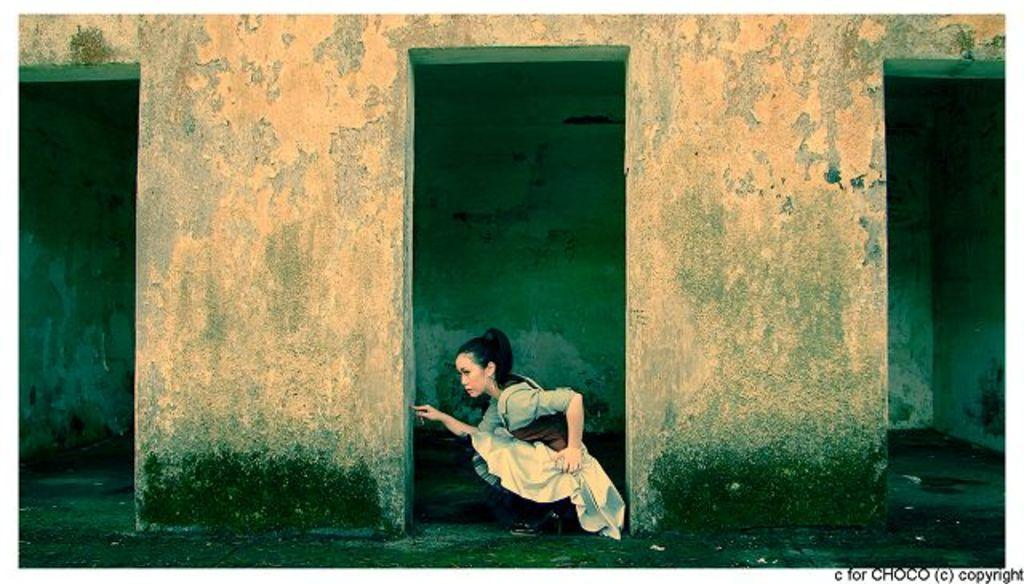Who is the main subject in the image? There is a woman in the image. Can you describe the woman's position in relation to the pillars? The woman is positioned between pillars. What can be seen behind the woman in the image? There is a wall visible behind the woman. What type of bulb is being used for the woman's treatment in the image? There is no indication of any treatment or bulb in the image; it simply features a woman positioned between pillars with a wall visible behind her. 